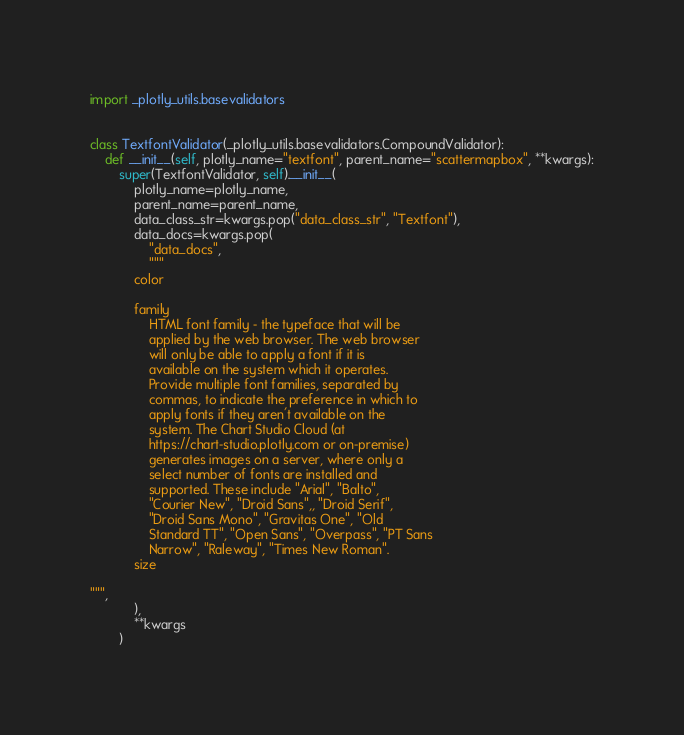Convert code to text. <code><loc_0><loc_0><loc_500><loc_500><_Python_>import _plotly_utils.basevalidators


class TextfontValidator(_plotly_utils.basevalidators.CompoundValidator):
    def __init__(self, plotly_name="textfont", parent_name="scattermapbox", **kwargs):
        super(TextfontValidator, self).__init__(
            plotly_name=plotly_name,
            parent_name=parent_name,
            data_class_str=kwargs.pop("data_class_str", "Textfont"),
            data_docs=kwargs.pop(
                "data_docs",
                """
            color

            family
                HTML font family - the typeface that will be
                applied by the web browser. The web browser
                will only be able to apply a font if it is
                available on the system which it operates.
                Provide multiple font families, separated by
                commas, to indicate the preference in which to
                apply fonts if they aren't available on the
                system. The Chart Studio Cloud (at
                https://chart-studio.plotly.com or on-premise)
                generates images on a server, where only a
                select number of fonts are installed and
                supported. These include "Arial", "Balto",
                "Courier New", "Droid Sans",, "Droid Serif",
                "Droid Sans Mono", "Gravitas One", "Old
                Standard TT", "Open Sans", "Overpass", "PT Sans
                Narrow", "Raleway", "Times New Roman".
            size

""",
            ),
            **kwargs
        )
</code> 